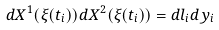Convert formula to latex. <formula><loc_0><loc_0><loc_500><loc_500>d X ^ { 1 } ( \xi ( t _ { i } ) ) d X ^ { 2 } ( \xi ( t _ { i } ) ) = d l _ { i } d y _ { i }</formula> 